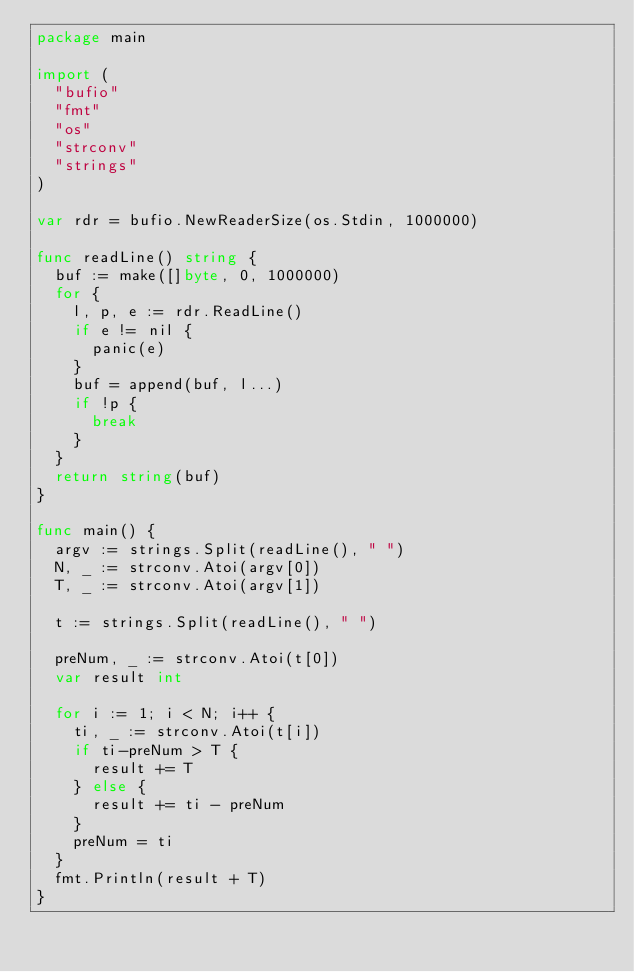Convert code to text. <code><loc_0><loc_0><loc_500><loc_500><_Go_>package main

import (
	"bufio"
	"fmt"
	"os"
	"strconv"
	"strings"
)

var rdr = bufio.NewReaderSize(os.Stdin, 1000000)

func readLine() string {
	buf := make([]byte, 0, 1000000)
	for {
		l, p, e := rdr.ReadLine()
		if e != nil {
			panic(e)
		}
		buf = append(buf, l...)
		if !p {
			break
		}
	}
	return string(buf)
}

func main() {
	argv := strings.Split(readLine(), " ")
	N, _ := strconv.Atoi(argv[0])
	T, _ := strconv.Atoi(argv[1])

	t := strings.Split(readLine(), " ")

	preNum, _ := strconv.Atoi(t[0])
	var result int

	for i := 1; i < N; i++ {
		ti, _ := strconv.Atoi(t[i])
		if ti-preNum > T {
			result += T
		} else {
			result += ti - preNum
		}
		preNum = ti
	}
	fmt.Println(result + T)
}
</code> 